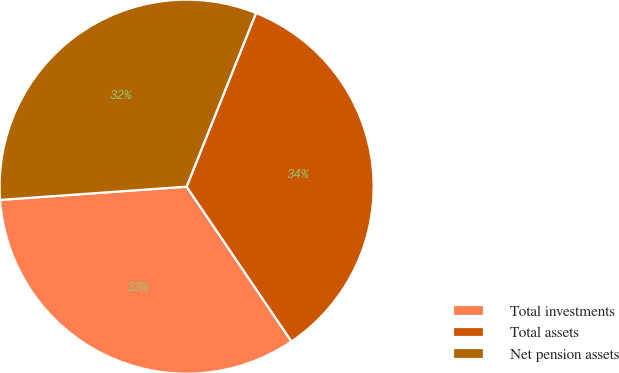<chart> <loc_0><loc_0><loc_500><loc_500><pie_chart><fcel>Total investments<fcel>Total assets<fcel>Net pension assets<nl><fcel>33.35%<fcel>34.47%<fcel>32.18%<nl></chart> 